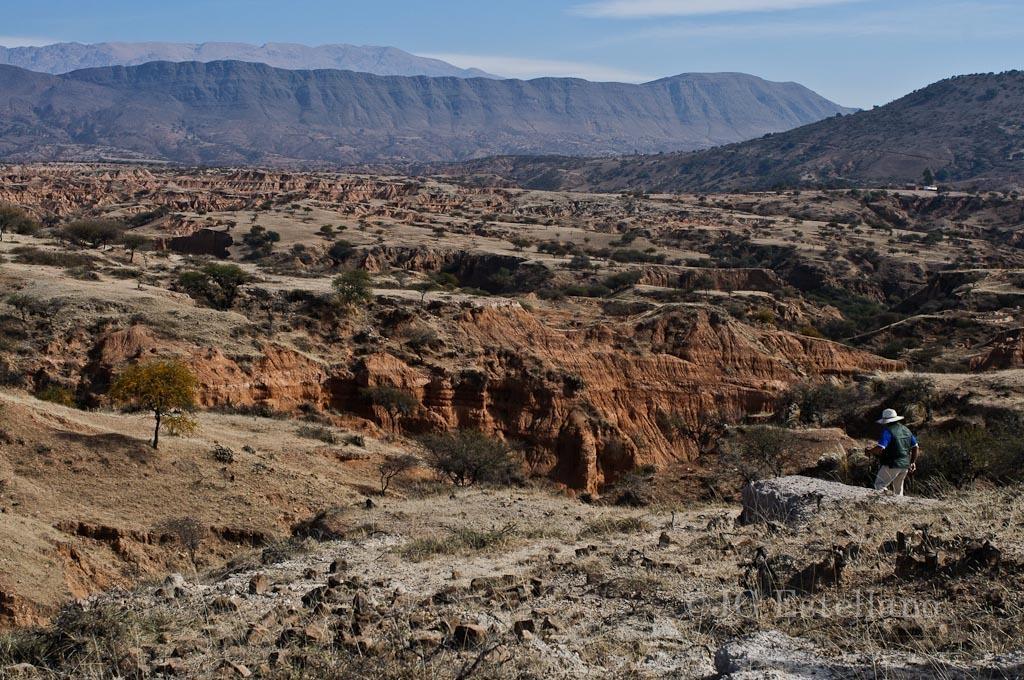How would you summarize this image in a sentence or two? In this image, we can see a person wearing a hat and standing and there are trees. In the background, there are mountains and at the top, there is sky. 